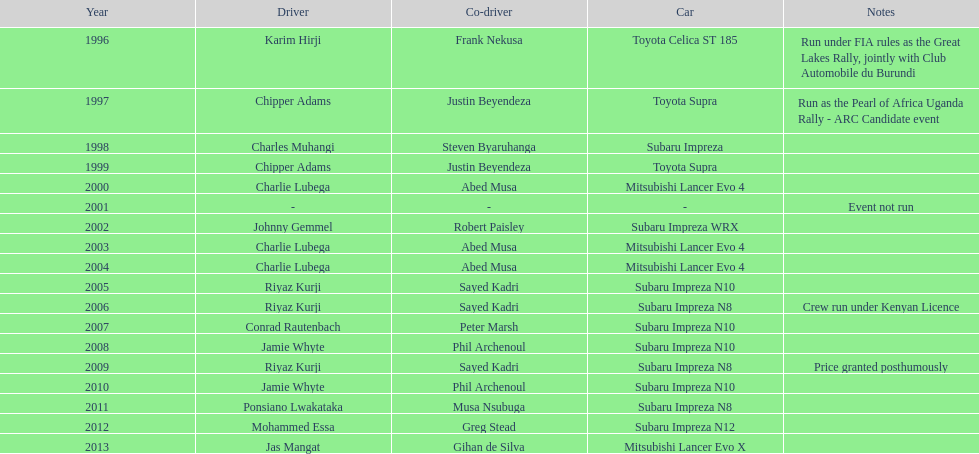Do chipper adams and justin beyendeza have more than 3 wins? No. 